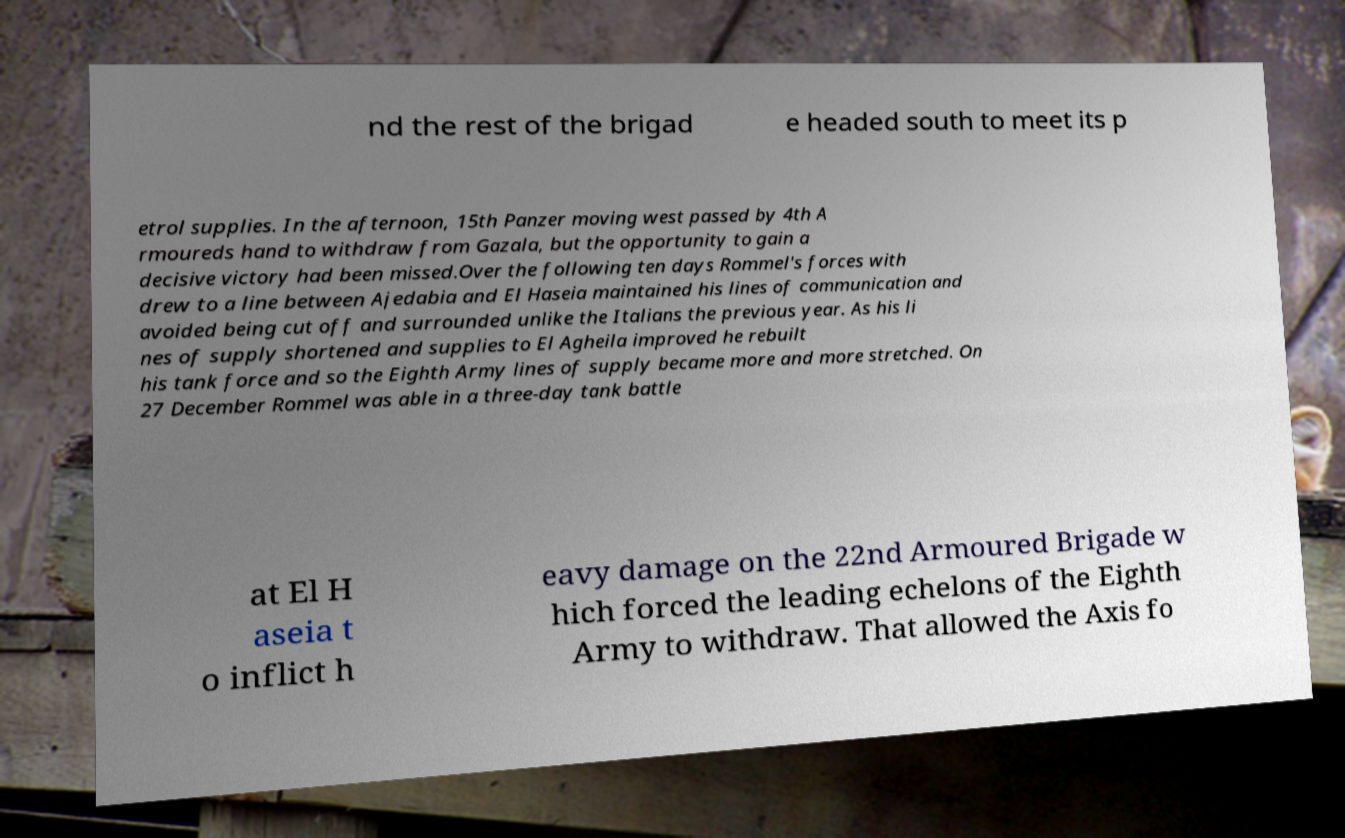Please read and relay the text visible in this image. What does it say? nd the rest of the brigad e headed south to meet its p etrol supplies. In the afternoon, 15th Panzer moving west passed by 4th A rmoureds hand to withdraw from Gazala, but the opportunity to gain a decisive victory had been missed.Over the following ten days Rommel's forces with drew to a line between Ajedabia and El Haseia maintained his lines of communication and avoided being cut off and surrounded unlike the Italians the previous year. As his li nes of supply shortened and supplies to El Agheila improved he rebuilt his tank force and so the Eighth Army lines of supply became more and more stretched. On 27 December Rommel was able in a three-day tank battle at El H aseia t o inflict h eavy damage on the 22nd Armoured Brigade w hich forced the leading echelons of the Eighth Army to withdraw. That allowed the Axis fo 